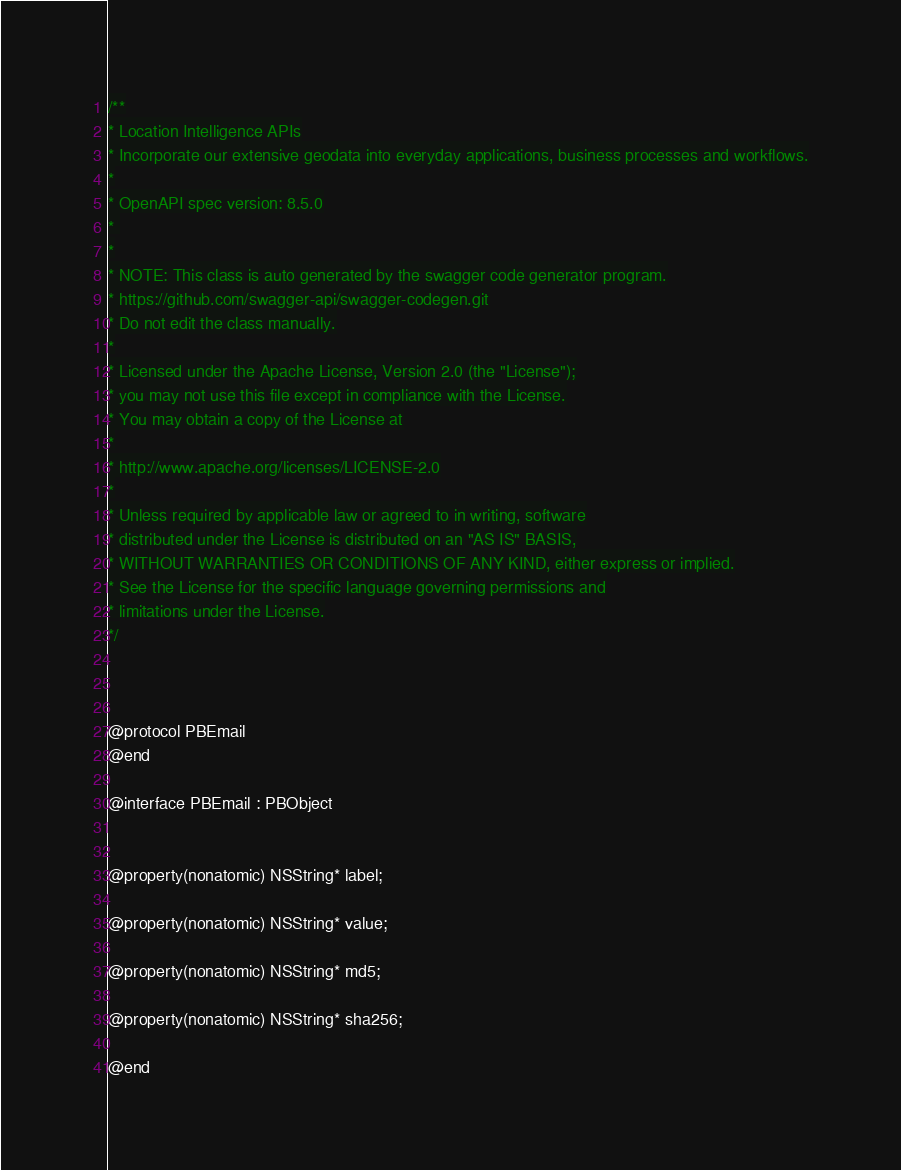<code> <loc_0><loc_0><loc_500><loc_500><_C_>
/**
* Location Intelligence APIs
* Incorporate our extensive geodata into everyday applications, business processes and workflows.
*
* OpenAPI spec version: 8.5.0
* 
*
* NOTE: This class is auto generated by the swagger code generator program.
* https://github.com/swagger-api/swagger-codegen.git
* Do not edit the class manually.
*
* Licensed under the Apache License, Version 2.0 (the "License");
* you may not use this file except in compliance with the License.
* You may obtain a copy of the License at
*
* http://www.apache.org/licenses/LICENSE-2.0
*
* Unless required by applicable law or agreed to in writing, software
* distributed under the License is distributed on an "AS IS" BASIS,
* WITHOUT WARRANTIES OR CONDITIONS OF ANY KIND, either express or implied.
* See the License for the specific language governing permissions and
* limitations under the License.
*/



@protocol PBEmail
@end

@interface PBEmail : PBObject


@property(nonatomic) NSString* label;

@property(nonatomic) NSString* value;

@property(nonatomic) NSString* md5;

@property(nonatomic) NSString* sha256;

@end
</code> 